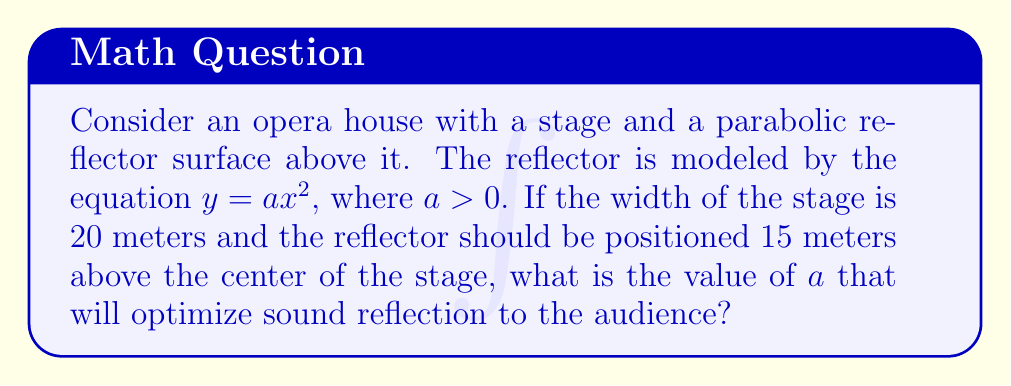Can you answer this question? To solve this problem, we'll follow these steps:

1) The parabola is given by $y = ax^2$, where $a > 0$.

2) The width of the stage is 20 meters, so the x-coordinates of the stage edges are at $x = -10$ and $x = 10$.

3) The reflector should be 15 meters above the center of the stage. The center of the stage is at $x = 0$, so we need:

   $y(0) = a(0)^2 = 0 = 15$

   This condition is automatically satisfied for any $a$.

4) To ensure the reflector covers the entire stage width and is positioned correctly, we need:

   $y(10) = a(10)^2 = 100a = 15$

5) Solving for $a$:

   $100a = 15$
   $a = \frac{15}{100} = 0.15$

6) To verify, let's check $y(-10)$:

   $y(-10) = 0.15(-10)^2 = 0.15(100) = 15$

   This confirms that the reflector is 15 meters above both edges of the stage.

7) The equation of the optimal parabolic reflector is thus:

   $y = 0.15x^2$

This parabola will effectively reflect sound from the stage to the audience, optimizing the acoustics in the opera house.
Answer: $a = 0.15$ 